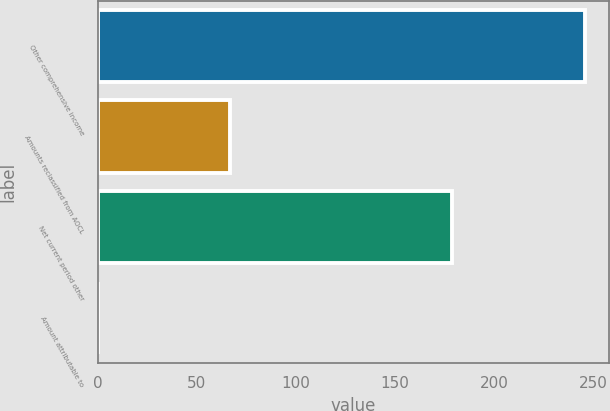Convert chart to OTSL. <chart><loc_0><loc_0><loc_500><loc_500><bar_chart><fcel>Other comprehensive income<fcel>Amounts reclassified from AOCL<fcel>Net current period other<fcel>Amount attributable to<nl><fcel>246<fcel>67<fcel>179<fcel>0.2<nl></chart> 